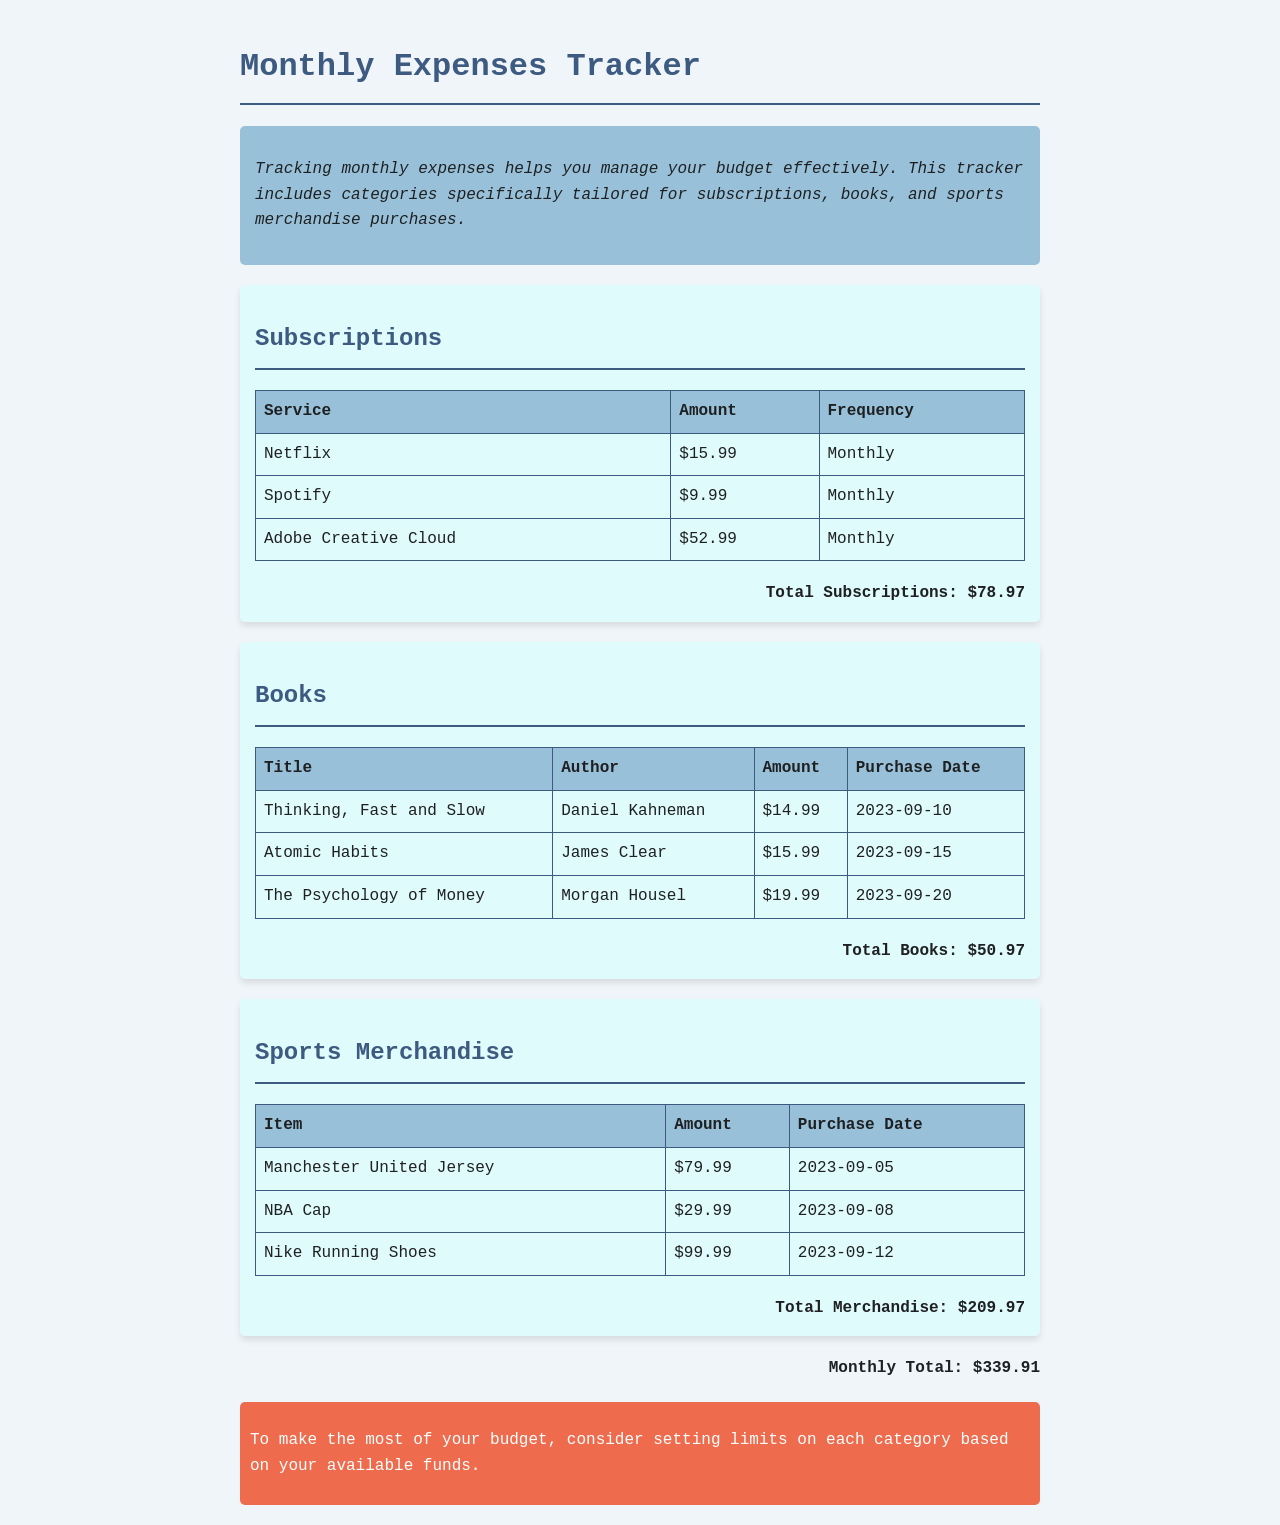What is the total amount spent on subscriptions? The total amount spent on subscriptions is listed under the Subscriptions section, which sums to $78.97.
Answer: $78.97 Who is the author of "Atomic Habits"? The author of "Atomic Habits" is mentioned in the Books section, specifically as James Clear.
Answer: James Clear What item was purchased on September 12, 2023? The purchase date is connected to the merchandise in the Sports Merchandise section, with "Nike Running Shoes" being the item bought on that date.
Answer: Nike Running Shoes What is the total for sports merchandise purchases? The total for sports merchandise purchases can be found in the Sports Merchandise section, which totals $209.97.
Answer: $209.97 When was "Thinking, Fast and Slow" purchased? The purchase date of "Thinking, Fast and Slow" is specified in the Books section, which shows it was purchased on September 10, 2023.
Answer: 2023-09-10 How much is the Adobe Creative Cloud subscription? The amount for the Adobe Creative Cloud subscription is detailed in the Subscriptions section, showing $52.99.
Answer: $52.99 What is the monthly total of all expenses? The monthly total is listed at the end of the document, summing all categories to a total of $339.91.
Answer: $339.91 What type of document is this? This document serves as a tracker specifically for monthly expenses including various categories.
Answer: Monthly Expenses Tracker 